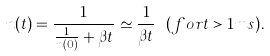Convert formula to latex. <formula><loc_0><loc_0><loc_500><loc_500>n ( t ) = \frac { 1 } { \frac { 1 } { n ( 0 ) } + \beta t } \simeq \frac { 1 } { \beta t } \ ( f o r t > 1 m s ) .</formula> 